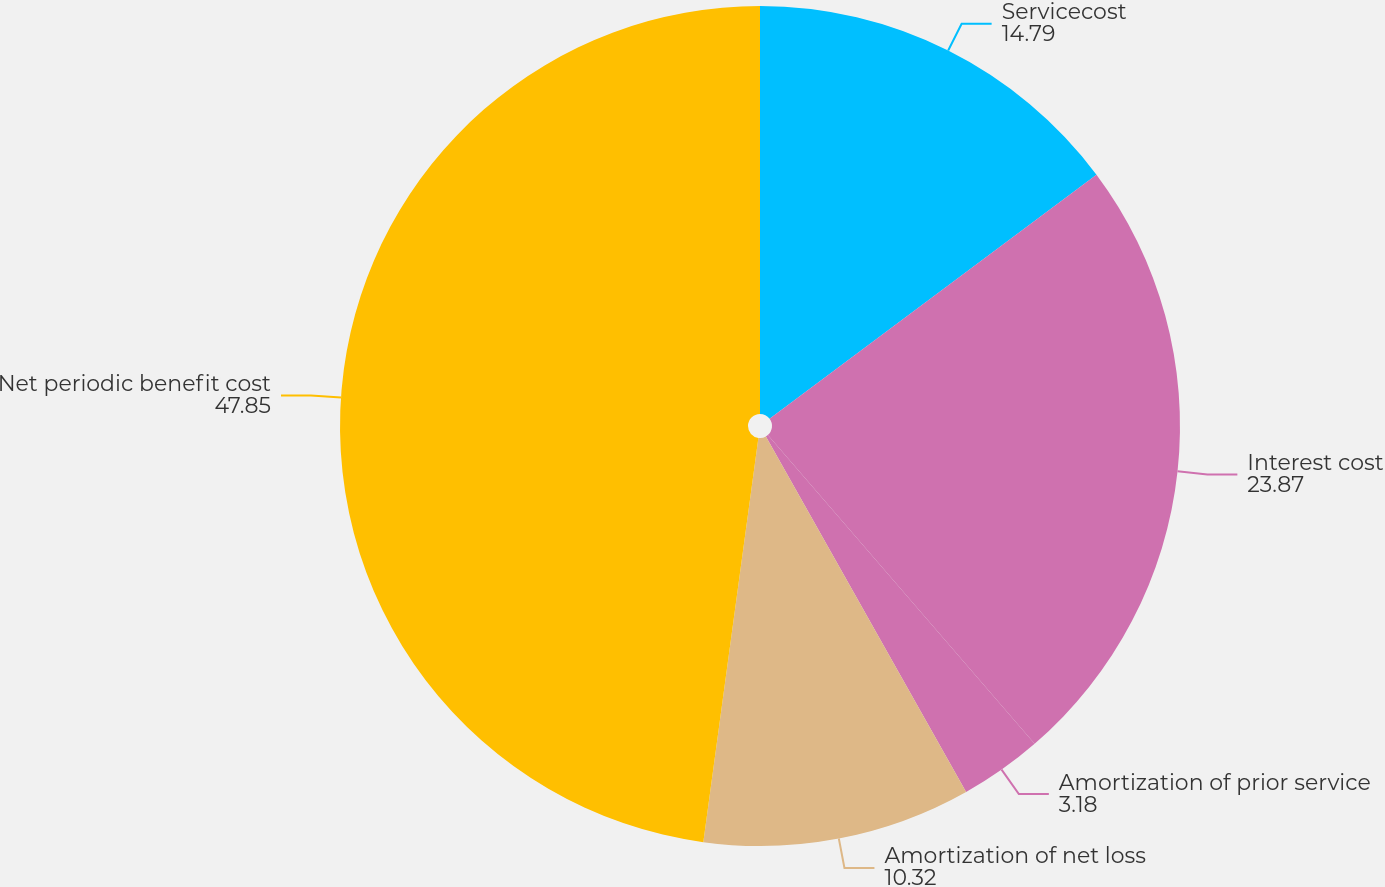Convert chart. <chart><loc_0><loc_0><loc_500><loc_500><pie_chart><fcel>Servicecost<fcel>Interest cost<fcel>Amortization of prior service<fcel>Amortization of net loss<fcel>Net periodic benefit cost<nl><fcel>14.79%<fcel>23.87%<fcel>3.18%<fcel>10.32%<fcel>47.85%<nl></chart> 